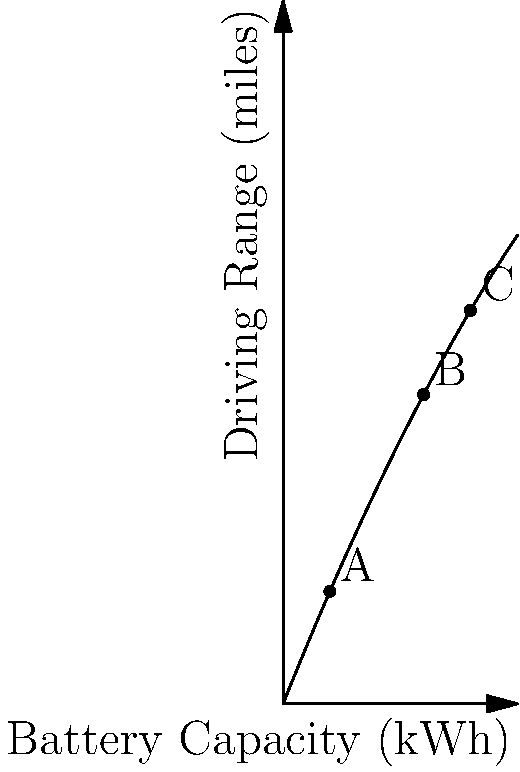A classic car enthusiast is converting their vintage vehicle to electric. The graph shows the relationship between battery capacity and driving range, considering the added weight of larger batteries. If the optimal driving range is achieved at point B, what is the approximate battery capacity (in kWh) that maximizes the driving range? To solve this problem, we'll follow these steps:

1. Understand the graph:
   - The x-axis represents battery capacity in kWh
   - The y-axis represents driving range in miles
   - The curve shows how driving range changes with battery capacity

2. Identify the key points:
   - Point A: Lower battery capacity
   - Point B: Optimal point (maximum driving range)
   - Point C: Higher battery capacity

3. Analyze the curve:
   - The curve increases rapidly at first, then peaks, and finally decreases
   - This shape reflects the trade-off between battery capacity and added weight

4. Locate the optimal point:
   - Point B is given as the optimal point in the question
   - This is where the driving range is maximized

5. Estimate the x-coordinate of Point B:
   - Point B appears to be at approximately 60 kWh on the x-axis

Therefore, the battery capacity that maximizes the driving range is approximately 60 kWh.
Answer: 60 kWh 